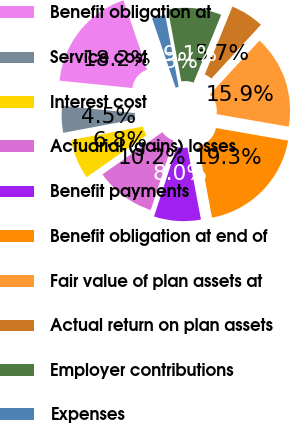Convert chart to OTSL. <chart><loc_0><loc_0><loc_500><loc_500><pie_chart><fcel>Benefit obligation at<fcel>Service cost<fcel>Interest cost<fcel>Actuarial (gains) losses<fcel>Benefit payments<fcel>Benefit obligation at end of<fcel>Fair value of plan assets at<fcel>Actual return on plan assets<fcel>Employer contributions<fcel>Expenses<nl><fcel>18.18%<fcel>4.55%<fcel>6.82%<fcel>10.23%<fcel>7.96%<fcel>19.31%<fcel>15.9%<fcel>5.69%<fcel>9.09%<fcel>2.28%<nl></chart> 